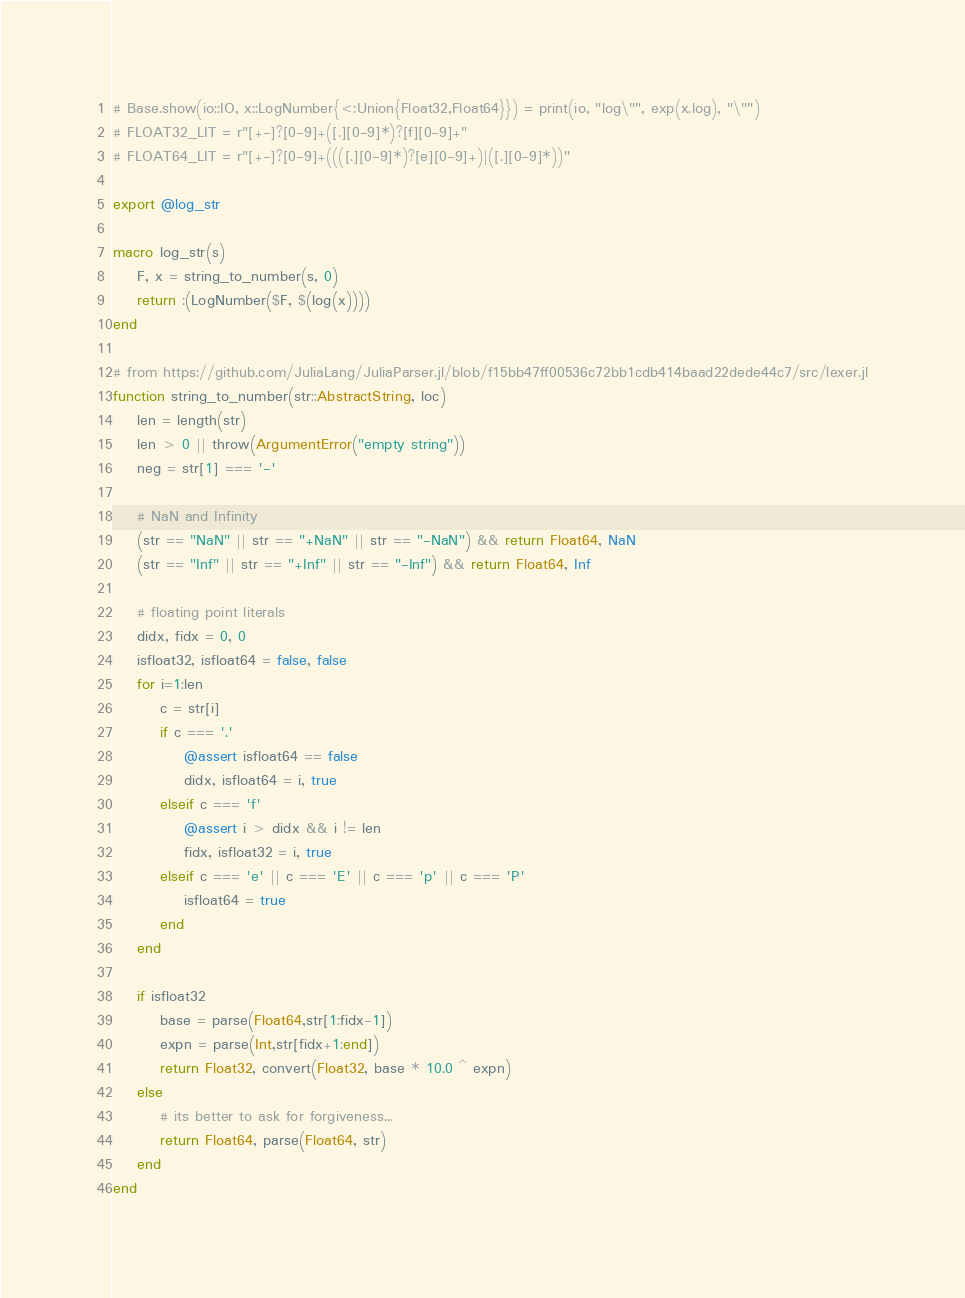Convert code to text. <code><loc_0><loc_0><loc_500><loc_500><_Julia_># Base.show(io::IO, x::LogNumber{<:Union{Float32,Float64}}) = print(io, "log\"", exp(x.log), "\"")
# FLOAT32_LIT = r"[+-]?[0-9]+([.][0-9]*)?[f][0-9]+"
# FLOAT64_LIT = r"[+-]?[0-9]+((([.][0-9]*)?[e][0-9]+)|([.][0-9]*))"

export @log_str

macro log_str(s)
    F, x = string_to_number(s, 0)
    return :(LogNumber($F, $(log(x))))
end

# from https://github.com/JuliaLang/JuliaParser.jl/blob/f15bb47ff00536c72bb1cdb414baad22dede44c7/src/lexer.jl
function string_to_number(str::AbstractString, loc)
    len = length(str)
    len > 0 || throw(ArgumentError("empty string"))
    neg = str[1] === '-'
    
    # NaN and Infinity
    (str == "NaN" || str == "+NaN" || str == "-NaN") && return Float64, NaN
    (str == "Inf" || str == "+Inf" || str == "-Inf") && return Float64, Inf
    
    # floating point literals
    didx, fidx = 0, 0
    isfloat32, isfloat64 = false, false
    for i=1:len
        c = str[i]
        if c === '.'
            @assert isfloat64 == false
            didx, isfloat64 = i, true
        elseif c === 'f'
            @assert i > didx && i != len
            fidx, isfloat32 = i, true
        elseif c === 'e' || c === 'E' || c === 'p' || c === 'P'
            isfloat64 = true
        end
    end
    
    if isfloat32
        base = parse(Float64,str[1:fidx-1])
        expn = parse(Int,str[fidx+1:end])
        return Float32, convert(Float32, base * 10.0 ^ expn)
    else
        # its better to ask for forgiveness...
        return Float64, parse(Float64, str)
    end
end
</code> 